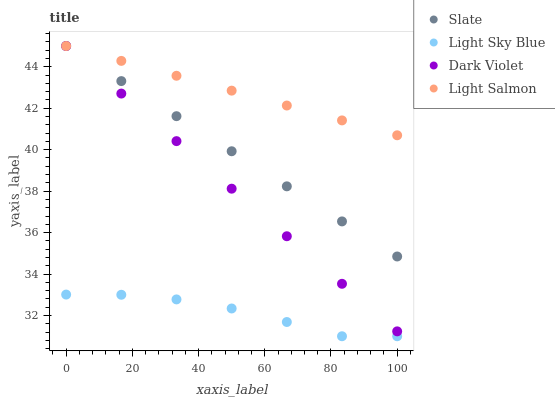Does Light Sky Blue have the minimum area under the curve?
Answer yes or no. Yes. Does Light Salmon have the maximum area under the curve?
Answer yes or no. Yes. Does Light Salmon have the minimum area under the curve?
Answer yes or no. No. Does Light Sky Blue have the maximum area under the curve?
Answer yes or no. No. Is Light Salmon the smoothest?
Answer yes or no. Yes. Is Light Sky Blue the roughest?
Answer yes or no. Yes. Is Light Sky Blue the smoothest?
Answer yes or no. No. Is Light Salmon the roughest?
Answer yes or no. No. Does Light Sky Blue have the lowest value?
Answer yes or no. Yes. Does Light Salmon have the lowest value?
Answer yes or no. No. Does Dark Violet have the highest value?
Answer yes or no. Yes. Does Light Sky Blue have the highest value?
Answer yes or no. No. Is Light Sky Blue less than Dark Violet?
Answer yes or no. Yes. Is Light Salmon greater than Light Sky Blue?
Answer yes or no. Yes. Does Dark Violet intersect Slate?
Answer yes or no. Yes. Is Dark Violet less than Slate?
Answer yes or no. No. Is Dark Violet greater than Slate?
Answer yes or no. No. Does Light Sky Blue intersect Dark Violet?
Answer yes or no. No. 